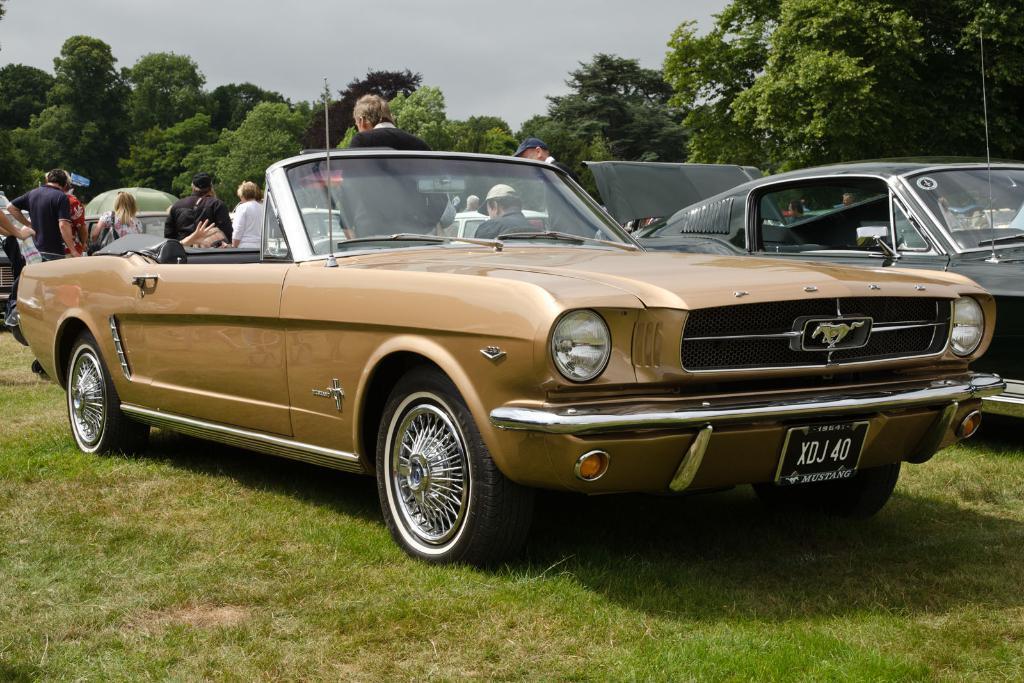Can you describe this image briefly? In the background we can see sky, trees. Here we can see people. These are vehicles. Here we can see headlights and number plate. Here we can see grass. 